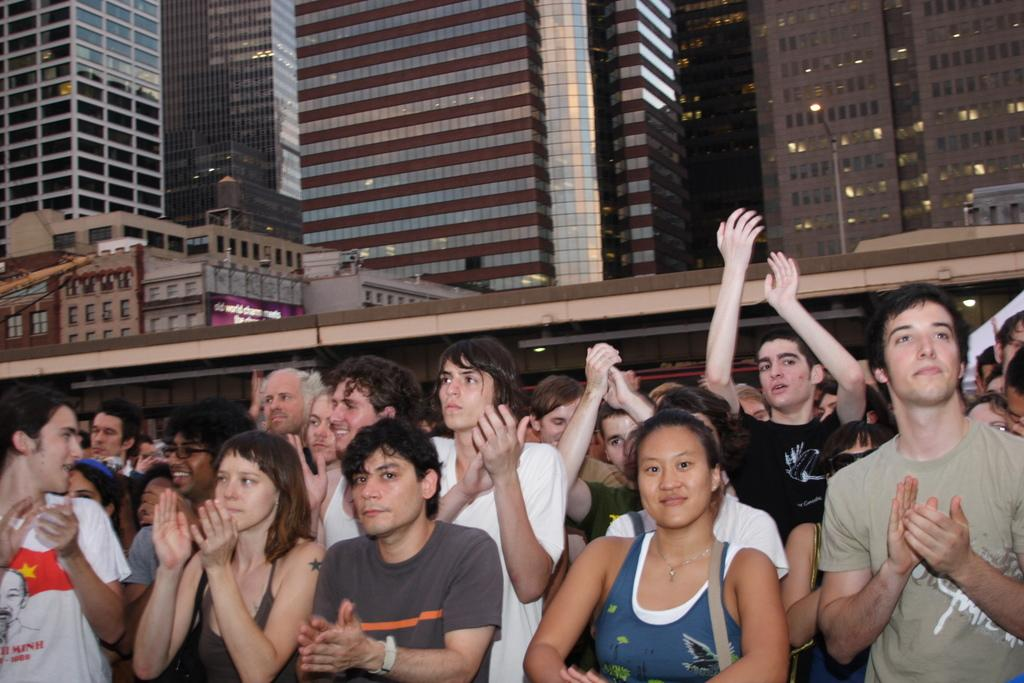What are the people in the image doing? The people in the image are cheering. What can be seen in the background of the image? There are buildings visible in the background of the image. What does the destruction of the buildings taste like in the image? There is no destruction of buildings present in the image, so it cannot be tasted. 